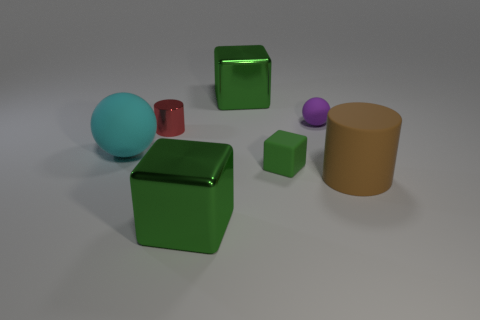Can you tell me how many objects are there in total, and what are their colors? In the image, there are five objects in total. Their colors are as follows: one large green cube, one smaller green cube, one turquoise blue sphere, one purple sphere, and one mustard yellow cylinder. 